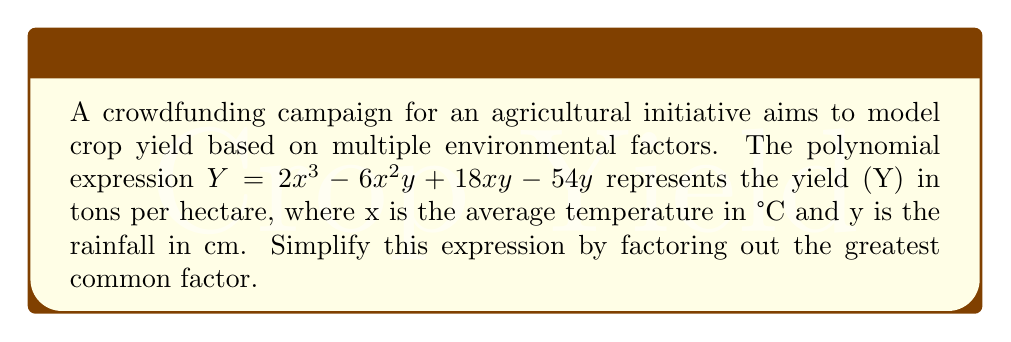Show me your answer to this math problem. To simplify this polynomial expression by factoring out the greatest common factor (GCF), we'll follow these steps:

1. Identify the terms in the polynomial:
   $2x^3$, $-6x^2y$, $18xy$, and $-54y$

2. Find the GCF of the coefficients:
   GCF of 2, -6, 18, and -54 is 2

3. Find the GCF of the variables:
   The variable y appears in three terms, but not all four, so it's not part of the overall GCF.
   There are no common variables across all terms.

4. Combine the numeric and variable GCFs:
   The overall GCF is 2

5. Factor out the GCF from each term:
   $$2(x^3 - 3x^2y + 9xy - 27y)$$

6. The expression inside the parentheses cannot be factored further, so this is our final simplified form.

This simplified form allows for easier analysis of how changes in temperature and rainfall affect crop yield in the agricultural initiative.
Answer: $2(x^3 - 3x^2y + 9xy - 27y)$ 